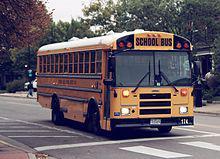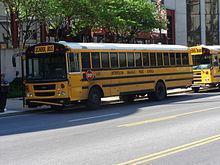The first image is the image on the left, the second image is the image on the right. For the images shown, is this caption "In at least one image there is a single bus with a closed front grill facing slightly right" true? Answer yes or no. Yes. The first image is the image on the left, the second image is the image on the right. Evaluate the accuracy of this statement regarding the images: "Each image shows a flat-fronted bus with a black-and-yellow striped line on its black bumper, and the buses on the left and right face the same direction.". Is it true? Answer yes or no. No. 